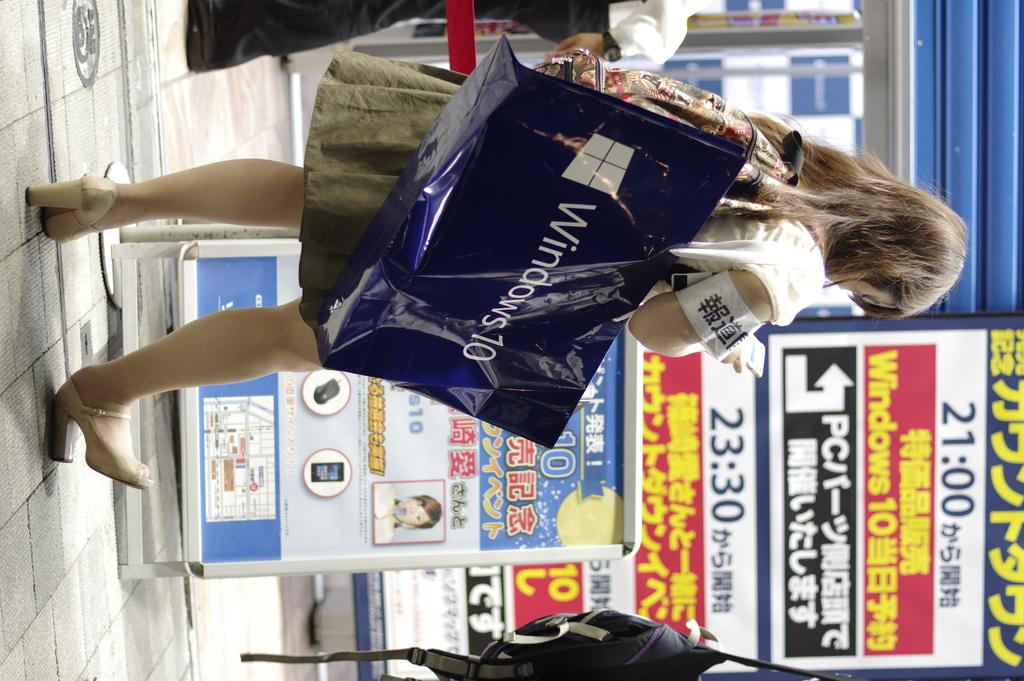<image>
Relay a brief, clear account of the picture shown. A woman walking in a shopping area carrying a bag that says Windows 10. 